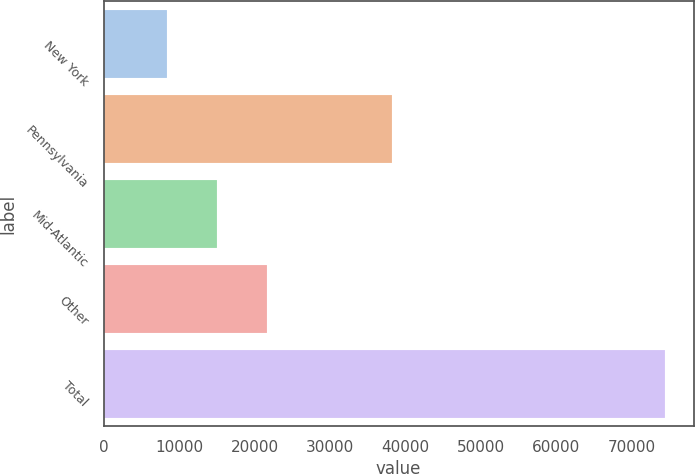Convert chart. <chart><loc_0><loc_0><loc_500><loc_500><bar_chart><fcel>New York<fcel>Pennsylvania<fcel>Mid-Atlantic<fcel>Other<fcel>Total<nl><fcel>8435<fcel>38255<fcel>15036.4<fcel>21637.8<fcel>74449<nl></chart> 